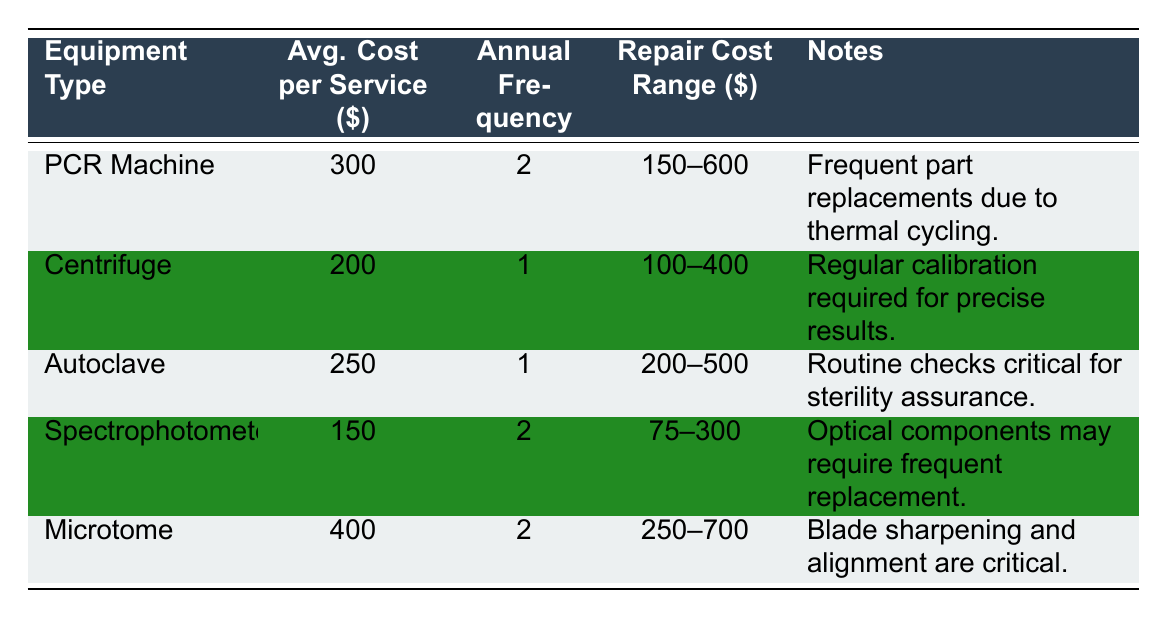What is the average cost per service for a PCR machine? From the table, the average cost per service for a PCR machine is listed as 300.
Answer: 300 How frequently is maintenance performed on a centrifuge? The table shows that maintenance for a centrifuge occurs once a year, indicated by the annual maintenance frequency of 1.
Answer: 1 time What is the repair cost range for an autoclave? The table specifies the repair cost range for an autoclave as 200 to 500. This is found in the corresponding row for the autoclave.
Answer: 200–500 True or false: The average cost per service for a spectrophotometer is less than that of a PCR machine. According to the table, the average cost per service for a spectrophotometer is 150, which is less than the 300 for a PCR machine. Therefore, the statement is true.
Answer: True What is the total average cost per service for all types of equipment listed? The average costs per service for all equipment types are 300 (PCR Machine), 200 (Centrifuge), 250 (Autoclave), 150 (Spectrophotometer), and 400 (Microtome). Summing these values gives 300 + 200 + 250 + 150 + 400 = 1300. To find the average, divide this sum by the number of equipment types, which is 5. Thus, the average is 1300 / 5 = 260.
Answer: 260 What equipment has the highest repair cost range? By examining the repair cost ranges in the table, the microtome has the highest range from 250 to 700, which is greater than the other equipment types.
Answer: Microtome How much more does it cost on average to service a microtome compared to a spectrophotometer? The average cost per service for a microtome is 400, while for a spectrophotometer it is 150. The difference is calculated as 400 - 150 = 250, indicating that servicing a microtome costs 250 more on average than servicing a spectrophotometer.
Answer: 250 True or false: The average service and repair costs for a centrifuge are higher than those for an autoclave. The average cost per service for a centrifuge is 200, and its repair cost range is 100 to 400. The average cost per service for an autoclave is 250, and its repair range is 200 to 500. As the average service cost for an autoclave is higher than that of a centrifuge, the statement is false.
Answer: False What is the minimum potential repair cost for a PCR machine? The table lists the repair cost range for a PCR machine with a minimum of 150. Therefore, the minimum potential repair cost for a PCR machine is 150.
Answer: 150 